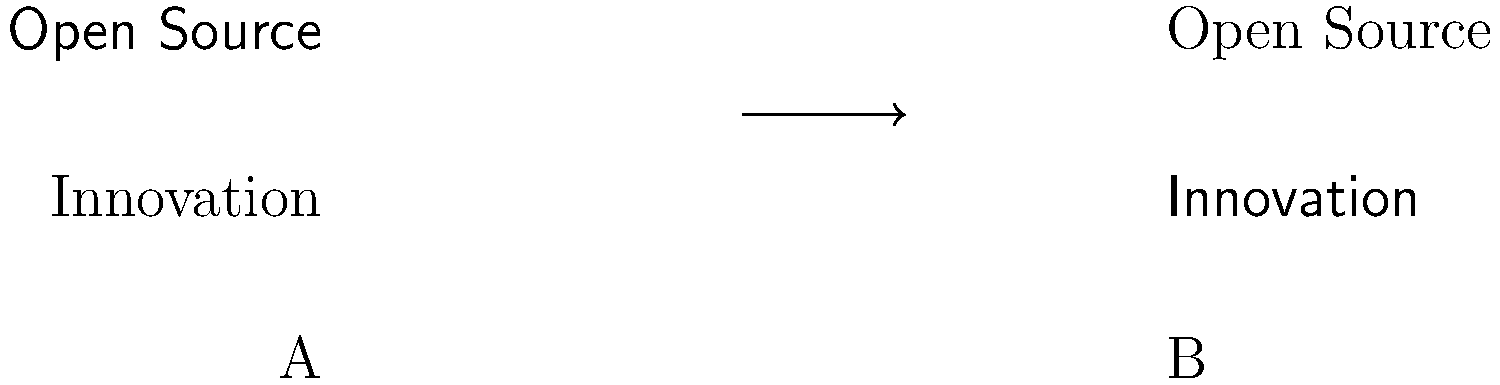Which typography pairing (A or B) is more suitable for an open source organization's marketing brochure aimed at promoting innovation? To determine the most appropriate typography pairing for an open source organization's marketing brochure, we need to consider the following factors:

1. Brand personality: Open source organizations often emphasize modernity, accessibility, and innovation.

2. Readability: The chosen fonts should be easy to read in both headlines and body text.

3. Contrast: A good pairing creates visual interest through contrast while maintaining harmony.

4. Message reinforcement: The fonts should support the organization's message of innovation.

Analyzing the options:

A. Sans-serif for "Open Source" and serif for "Innovation":
   - Sans-serif fonts are associated with modernity and simplicity, aligning with open source values.
   - Serif fonts can convey tradition and reliability, which may support the idea of innovation built on solid foundations.
   - This pairing creates a nice contrast between the two concepts.

B. Serif for "Open Source" and sans-serif for "Innovation":
   - Serif fonts for "Open Source" may convey a more traditional image, which doesn't align as well with the typical open source ethos.
   - Sans-serif for "Innovation" works well, as it suggests modernity and forward-thinking.
   - However, this pairing doesn't create as effective a contrast as option A.

Considering these factors, option A provides a better typography pairing for the organization's marketing brochure. It effectively communicates the open source nature of the organization while emphasizing innovation, creating a balanced and visually appealing design that aligns with the brand's values.
Answer: A 